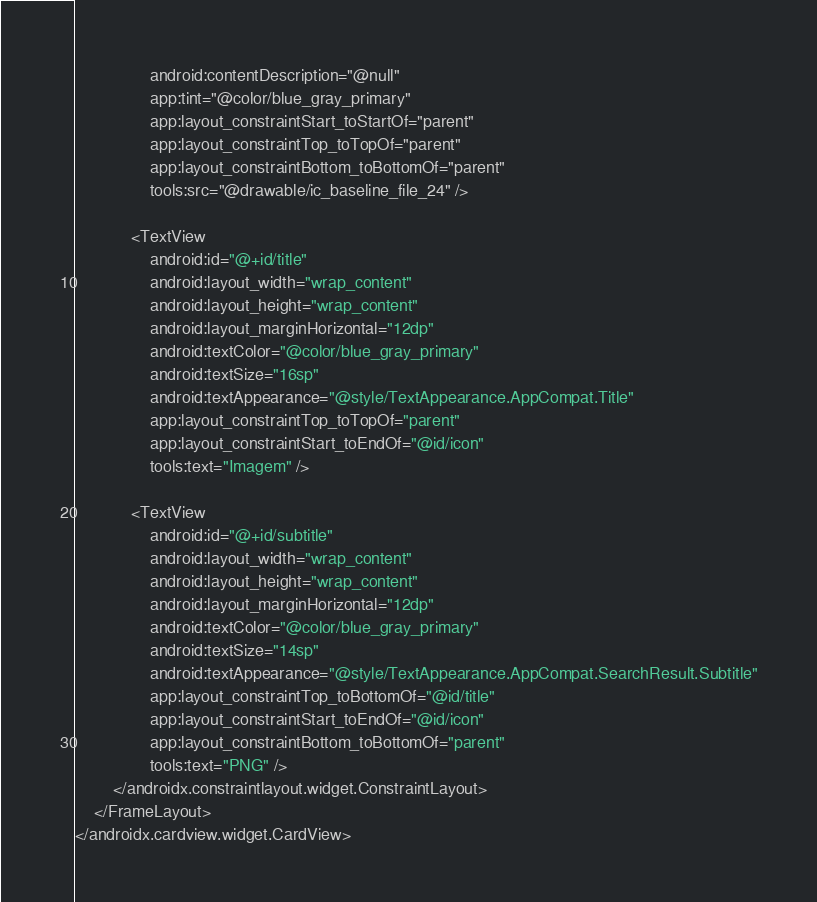Convert code to text. <code><loc_0><loc_0><loc_500><loc_500><_XML_>                android:contentDescription="@null"
                app:tint="@color/blue_gray_primary"
                app:layout_constraintStart_toStartOf="parent"
                app:layout_constraintTop_toTopOf="parent"
                app:layout_constraintBottom_toBottomOf="parent"
                tools:src="@drawable/ic_baseline_file_24" />

            <TextView
                android:id="@+id/title"
                android:layout_width="wrap_content"
                android:layout_height="wrap_content"
                android:layout_marginHorizontal="12dp"
                android:textColor="@color/blue_gray_primary"
                android:textSize="16sp"
                android:textAppearance="@style/TextAppearance.AppCompat.Title"
                app:layout_constraintTop_toTopOf="parent"
                app:layout_constraintStart_toEndOf="@id/icon"
                tools:text="Imagem" />

            <TextView
                android:id="@+id/subtitle"
                android:layout_width="wrap_content"
                android:layout_height="wrap_content"
                android:layout_marginHorizontal="12dp"
                android:textColor="@color/blue_gray_primary"
                android:textSize="14sp"
                android:textAppearance="@style/TextAppearance.AppCompat.SearchResult.Subtitle"
                app:layout_constraintTop_toBottomOf="@id/title"
                app:layout_constraintStart_toEndOf="@id/icon"
                app:layout_constraintBottom_toBottomOf="parent"
                tools:text="PNG" />
        </androidx.constraintlayout.widget.ConstraintLayout>
    </FrameLayout>
</androidx.cardview.widget.CardView></code> 